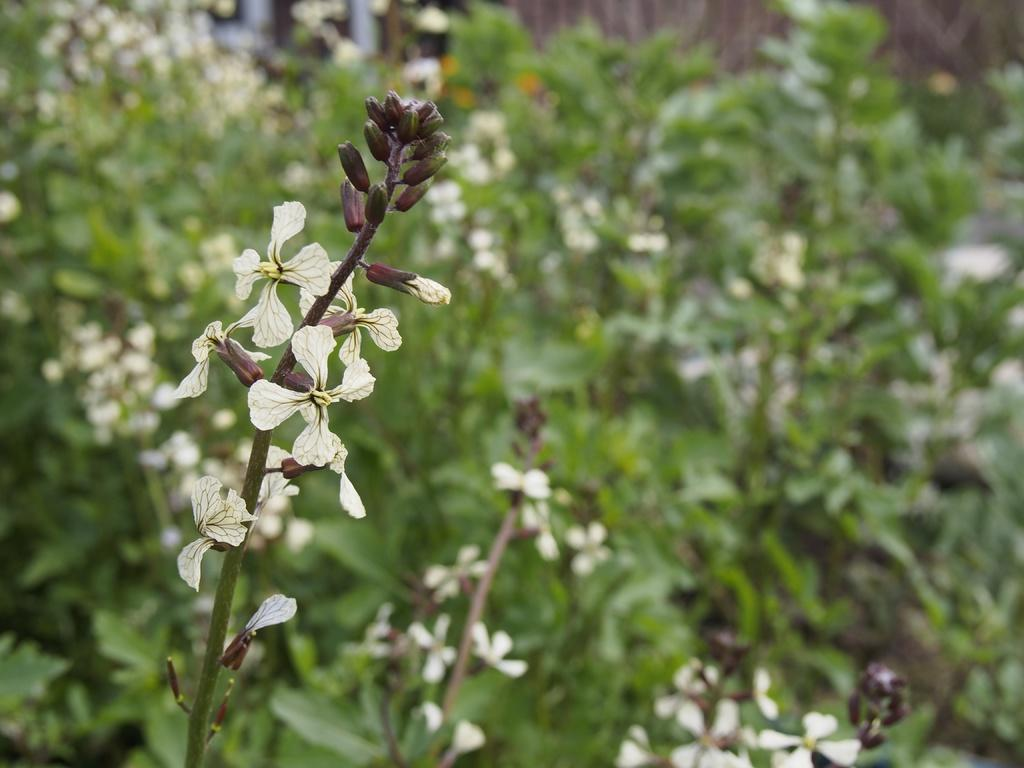What type of living organisms can be seen in the image? There are flowers on plants in the image. Can you describe the plants in the image? The plants in the image have flowers on them. How many zebras are visible in the image? There are no zebras present in the image; it features flowers on plants. What type of currency is being used in the image? There is no currency or money visible in the image. 